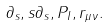Convert formula to latex. <formula><loc_0><loc_0><loc_500><loc_500>\partial _ { s } , s \partial _ { s } , P _ { I } , r _ { \mu \nu } .</formula> 